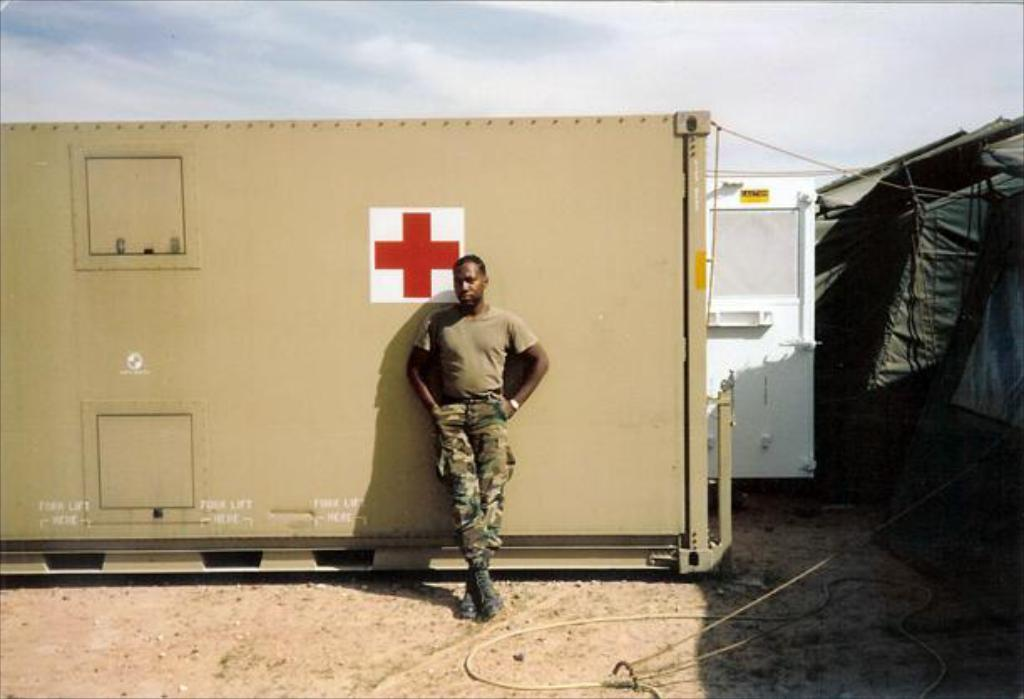What is the man doing in the image? The man is standing at a container in the image. What can be seen on the right side of the image? There is a tent on the right side of the image. What is visible in the background of the image? The sky is visible in the background of the image. What type of weather can be inferred from the background? Clouds are present in the background of the image, suggesting a partly cloudy day. What type of flowers does the man have to approve in the image? There are no flowers or approval process mentioned or depicted in the image. 